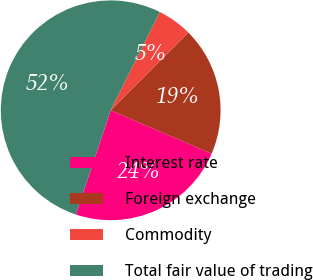Convert chart. <chart><loc_0><loc_0><loc_500><loc_500><pie_chart><fcel>Interest rate<fcel>Foreign exchange<fcel>Commodity<fcel>Total fair value of trading<nl><fcel>23.68%<fcel>18.97%<fcel>5.11%<fcel>52.23%<nl></chart> 